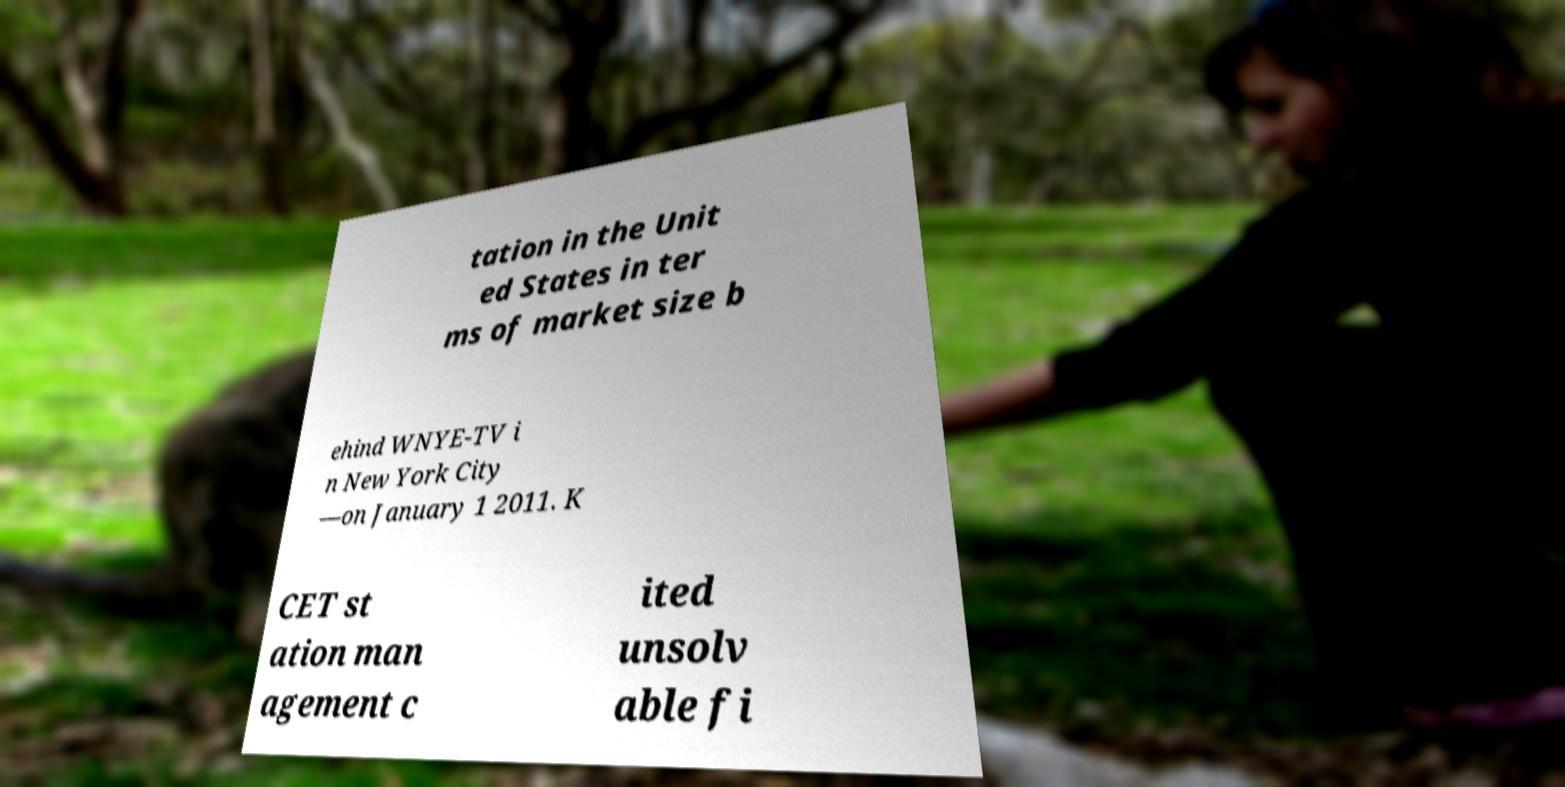Could you assist in decoding the text presented in this image and type it out clearly? tation in the Unit ed States in ter ms of market size b ehind WNYE-TV i n New York City —on January 1 2011. K CET st ation man agement c ited unsolv able fi 